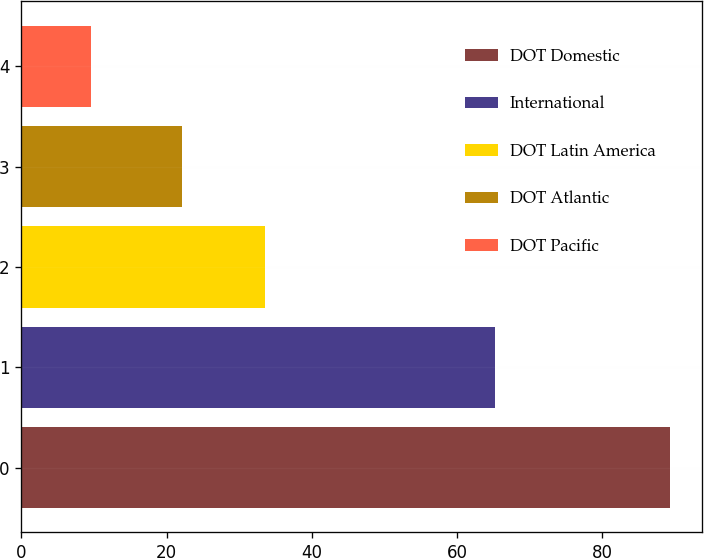Convert chart. <chart><loc_0><loc_0><loc_500><loc_500><bar_chart><fcel>DOT Domestic<fcel>International<fcel>DOT Latin America<fcel>DOT Atlantic<fcel>DOT Pacific<nl><fcel>89.3<fcel>65.2<fcel>33.5<fcel>22.1<fcel>9.6<nl></chart> 